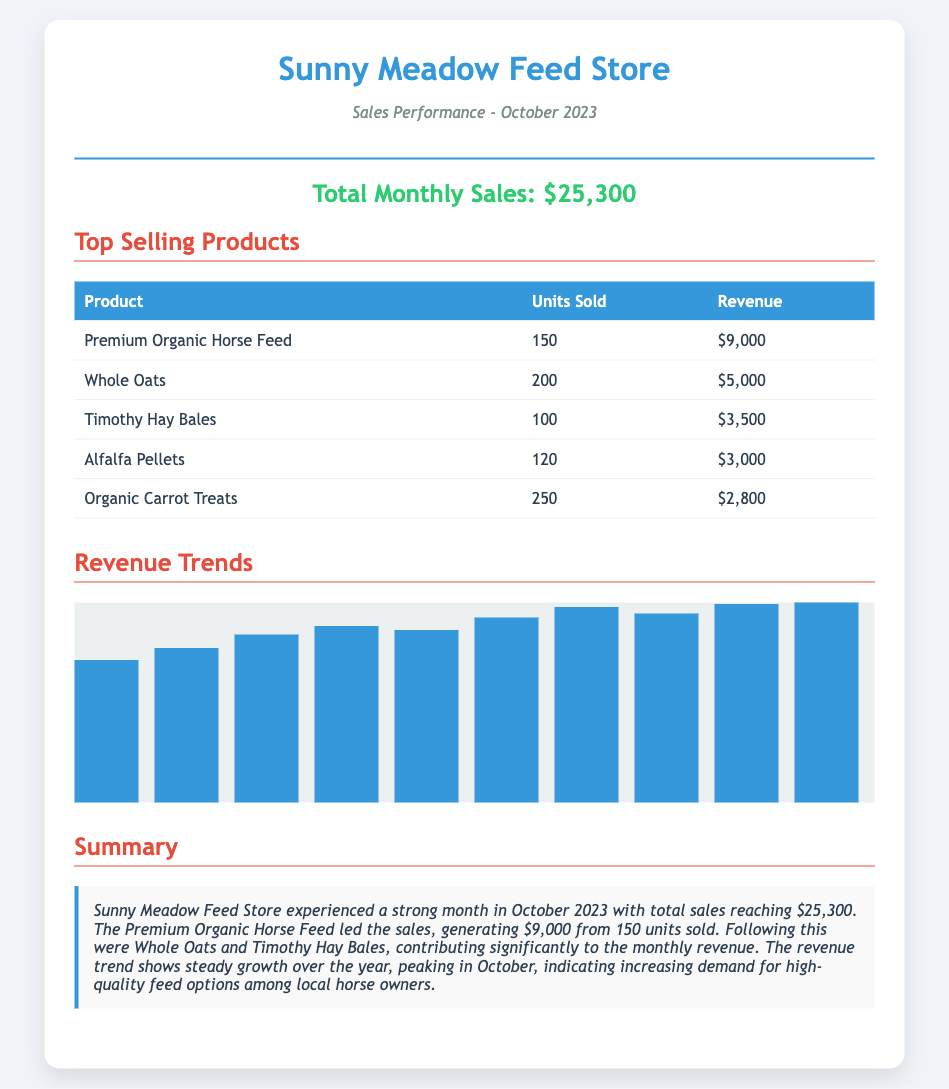What is the total monthly sales? The total monthly sales are clearly stated in the document as $25,300.
Answer: $25,300 What product sold the most units? The product with the highest units sold is Premium Organic Horse Feed, with 150 units sold.
Answer: Premium Organic Horse Feed How much revenue did Whole Oats generate? Whole Oats generated revenue that is listed in the document as $5,000.
Answer: $5,000 Which product had the lowest revenue? The product with the lowest revenue is Organic Carrot Treats, with a revenue of $2,800.
Answer: Organic Carrot Treats What was the revenue trend in October compared to previous months? The summary indicates a peak in revenue in October, showing increasing demand among local horse owners.
Answer: Steady growth How many units of Timothy Hay Bales were sold? The document specifies that 100 units of Timothy Hay Bales were sold.
Answer: 100 What is the highest revenue recorded for a single product? The highest revenue recorded for a single product is $9,000 from Premium Organic Horse Feed.
Answer: $9,000 How many products are listed in the top-selling products section? There are five products listed in the top-selling products section of the document.
Answer: Five What color is used for the header of the sales performance ticket? The document indicates that the header color is blue, as referenced by the color associated with the sales store name.
Answer: Blue 